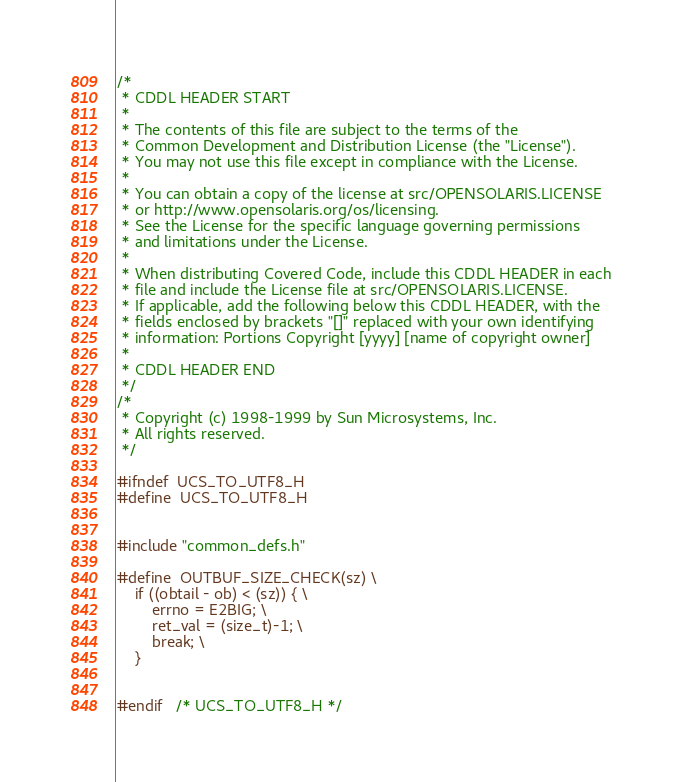Convert code to text. <code><loc_0><loc_0><loc_500><loc_500><_C_>/*
 * CDDL HEADER START
 *
 * The contents of this file are subject to the terms of the
 * Common Development and Distribution License (the "License").
 * You may not use this file except in compliance with the License.
 *
 * You can obtain a copy of the license at src/OPENSOLARIS.LICENSE
 * or http://www.opensolaris.org/os/licensing.
 * See the License for the specific language governing permissions
 * and limitations under the License.
 *
 * When distributing Covered Code, include this CDDL HEADER in each
 * file and include the License file at src/OPENSOLARIS.LICENSE.
 * If applicable, add the following below this CDDL HEADER, with the
 * fields enclosed by brackets "[]" replaced with your own identifying
 * information: Portions Copyright [yyyy] [name of copyright owner]
 *
 * CDDL HEADER END
 */
/*
 * Copyright (c) 1998-1999 by Sun Microsystems, Inc.
 * All rights reserved.
 */

#ifndef	UCS_TO_UTF8_H
#define	UCS_TO_UTF8_H


#include "common_defs.h"

#define	OUTBUF_SIZE_CHECK(sz) \
	if ((obtail - ob) < (sz)) { \
		errno = E2BIG; \
		ret_val = (size_t)-1; \
		break; \
	}


#endif	/* UCS_TO_UTF8_H */
</code> 